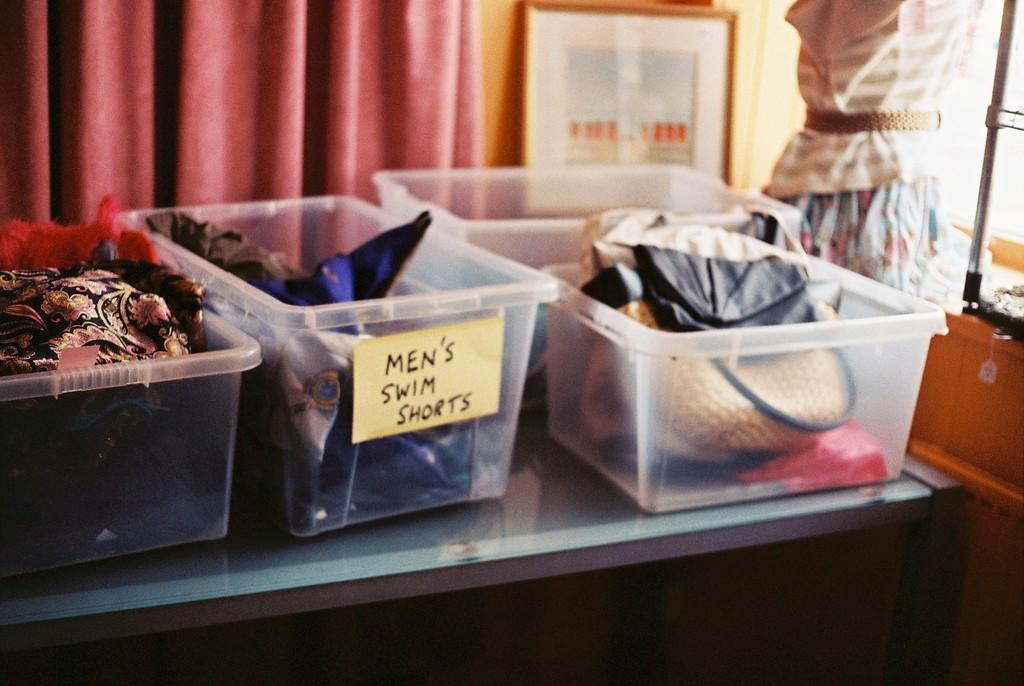Provide a one-sentence caption for the provided image. Small containers with one that says Men's Swim Shorts on it. 